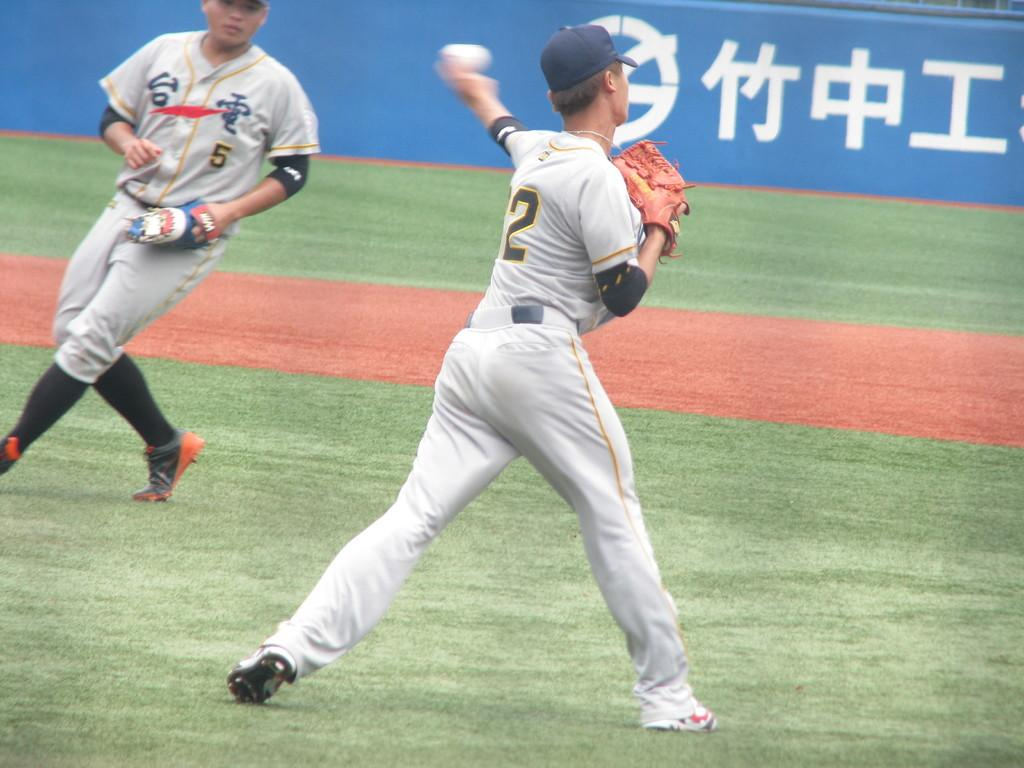Provide a one-sentence caption for the provided image. Player number two is throwing the ball to number 5. 